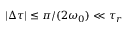Convert formula to latex. <formula><loc_0><loc_0><loc_500><loc_500>| \Delta \tau | \leq \pi / ( 2 \omega _ { 0 } ) \ll \tau _ { r }</formula> 